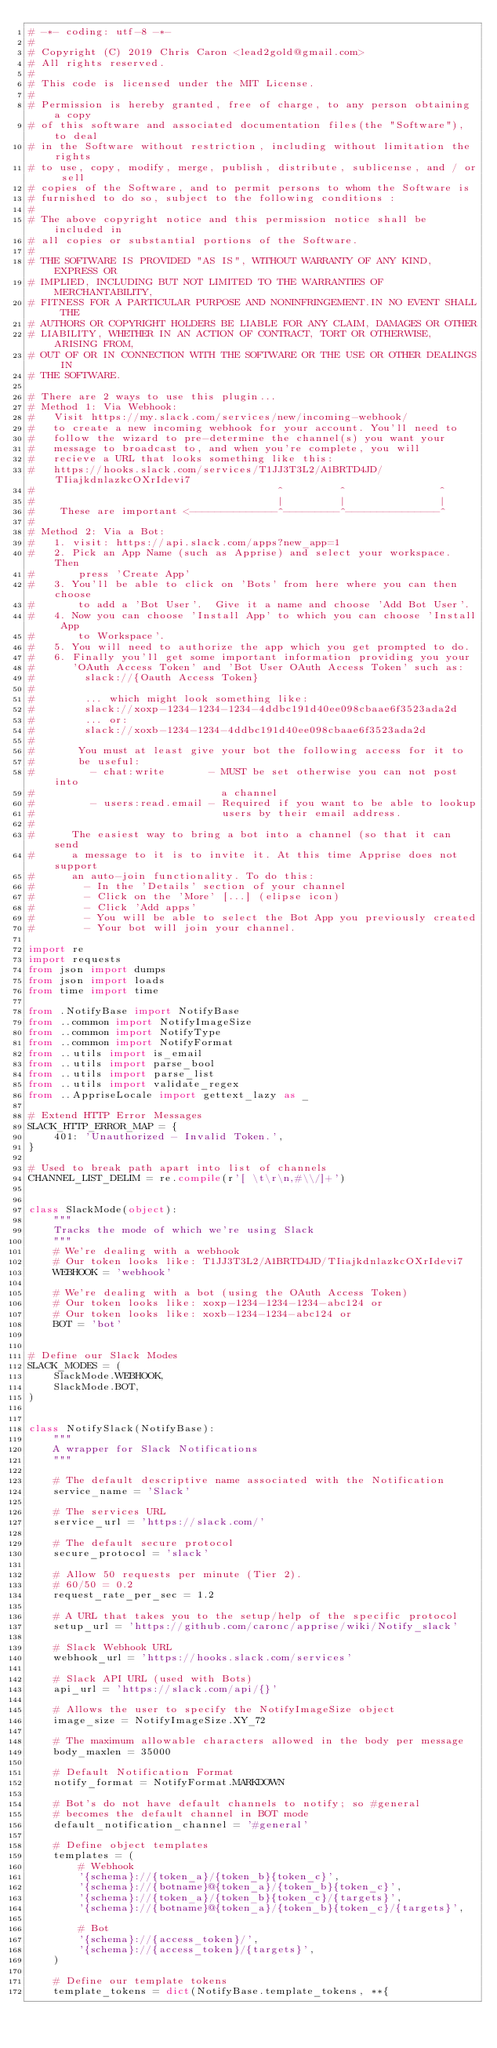<code> <loc_0><loc_0><loc_500><loc_500><_Python_># -*- coding: utf-8 -*-
#
# Copyright (C) 2019 Chris Caron <lead2gold@gmail.com>
# All rights reserved.
#
# This code is licensed under the MIT License.
#
# Permission is hereby granted, free of charge, to any person obtaining a copy
# of this software and associated documentation files(the "Software"), to deal
# in the Software without restriction, including without limitation the rights
# to use, copy, modify, merge, publish, distribute, sublicense, and / or sell
# copies of the Software, and to permit persons to whom the Software is
# furnished to do so, subject to the following conditions :
#
# The above copyright notice and this permission notice shall be included in
# all copies or substantial portions of the Software.
#
# THE SOFTWARE IS PROVIDED "AS IS", WITHOUT WARRANTY OF ANY KIND, EXPRESS OR
# IMPLIED, INCLUDING BUT NOT LIMITED TO THE WARRANTIES OF MERCHANTABILITY,
# FITNESS FOR A PARTICULAR PURPOSE AND NONINFRINGEMENT.IN NO EVENT SHALL THE
# AUTHORS OR COPYRIGHT HOLDERS BE LIABLE FOR ANY CLAIM, DAMAGES OR OTHER
# LIABILITY, WHETHER IN AN ACTION OF CONTRACT, TORT OR OTHERWISE, ARISING FROM,
# OUT OF OR IN CONNECTION WITH THE SOFTWARE OR THE USE OR OTHER DEALINGS IN
# THE SOFTWARE.

# There are 2 ways to use this plugin...
# Method 1: Via Webhook:
#   Visit https://my.slack.com/services/new/incoming-webhook/
#   to create a new incoming webhook for your account. You'll need to
#   follow the wizard to pre-determine the channel(s) you want your
#   message to broadcast to, and when you're complete, you will
#   recieve a URL that looks something like this:
#   https://hooks.slack.com/services/T1JJ3T3L2/A1BRTD4JD/TIiajkdnlazkcOXrIdevi7
#                                       ^         ^               ^
#                                       |         |               |
#    These are important <--------------^---------^---------------^
#
# Method 2: Via a Bot:
#   1. visit: https://api.slack.com/apps?new_app=1
#   2. Pick an App Name (such as Apprise) and select your workspace.  Then
#       press 'Create App'
#   3. You'll be able to click on 'Bots' from here where you can then choose
#       to add a 'Bot User'.  Give it a name and choose 'Add Bot User'.
#   4. Now you can choose 'Install App' to which you can choose 'Install App
#       to Workspace'.
#   5. You will need to authorize the app which you get prompted to do.
#   6. Finally you'll get some important information providing you your
#      'OAuth Access Token' and 'Bot User OAuth Access Token' such as:
#        slack://{Oauth Access Token}
#
#        ... which might look something like:
#        slack://xoxp-1234-1234-1234-4ddbc191d40ee098cbaae6f3523ada2d
#        ... or:
#        slack://xoxb-1234-1234-4ddbc191d40ee098cbaae6f3523ada2d
#
#       You must at least give your bot the following access for it to
#       be useful:
#         - chat:write       - MUST be set otherwise you can not post into
#                              a channel
#         - users:read.email - Required if you want to be able to lookup
#                              users by their email address.
#
#      The easiest way to bring a bot into a channel (so that it can send
#      a message to it is to invite it. At this time Apprise does not support
#      an auto-join functionality. To do this:
#        - In the 'Details' section of your channel
#        - Click on the 'More' [...] (elipse icon)
#        - Click 'Add apps'
#        - You will be able to select the Bot App you previously created
#        - Your bot will join your channel.

import re
import requests
from json import dumps
from json import loads
from time import time

from .NotifyBase import NotifyBase
from ..common import NotifyImageSize
from ..common import NotifyType
from ..common import NotifyFormat
from ..utils import is_email
from ..utils import parse_bool
from ..utils import parse_list
from ..utils import validate_regex
from ..AppriseLocale import gettext_lazy as _

# Extend HTTP Error Messages
SLACK_HTTP_ERROR_MAP = {
    401: 'Unauthorized - Invalid Token.',
}

# Used to break path apart into list of channels
CHANNEL_LIST_DELIM = re.compile(r'[ \t\r\n,#\\/]+')


class SlackMode(object):
    """
    Tracks the mode of which we're using Slack
    """
    # We're dealing with a webhook
    # Our token looks like: T1JJ3T3L2/A1BRTD4JD/TIiajkdnlazkcOXrIdevi7
    WEBHOOK = 'webhook'

    # We're dealing with a bot (using the OAuth Access Token)
    # Our token looks like: xoxp-1234-1234-1234-abc124 or
    # Our token looks like: xoxb-1234-1234-abc124 or
    BOT = 'bot'


# Define our Slack Modes
SLACK_MODES = (
    SlackMode.WEBHOOK,
    SlackMode.BOT,
)


class NotifySlack(NotifyBase):
    """
    A wrapper for Slack Notifications
    """

    # The default descriptive name associated with the Notification
    service_name = 'Slack'

    # The services URL
    service_url = 'https://slack.com/'

    # The default secure protocol
    secure_protocol = 'slack'

    # Allow 50 requests per minute (Tier 2).
    # 60/50 = 0.2
    request_rate_per_sec = 1.2

    # A URL that takes you to the setup/help of the specific protocol
    setup_url = 'https://github.com/caronc/apprise/wiki/Notify_slack'

    # Slack Webhook URL
    webhook_url = 'https://hooks.slack.com/services'

    # Slack API URL (used with Bots)
    api_url = 'https://slack.com/api/{}'

    # Allows the user to specify the NotifyImageSize object
    image_size = NotifyImageSize.XY_72

    # The maximum allowable characters allowed in the body per message
    body_maxlen = 35000

    # Default Notification Format
    notify_format = NotifyFormat.MARKDOWN

    # Bot's do not have default channels to notify; so #general
    # becomes the default channel in BOT mode
    default_notification_channel = '#general'

    # Define object templates
    templates = (
        # Webhook
        '{schema}://{token_a}/{token_b}{token_c}',
        '{schema}://{botname}@{token_a}/{token_b}{token_c}',
        '{schema}://{token_a}/{token_b}{token_c}/{targets}',
        '{schema}://{botname}@{token_a}/{token_b}{token_c}/{targets}',

        # Bot
        '{schema}://{access_token}/',
        '{schema}://{access_token}/{targets}',
    )

    # Define our template tokens
    template_tokens = dict(NotifyBase.template_tokens, **{</code> 